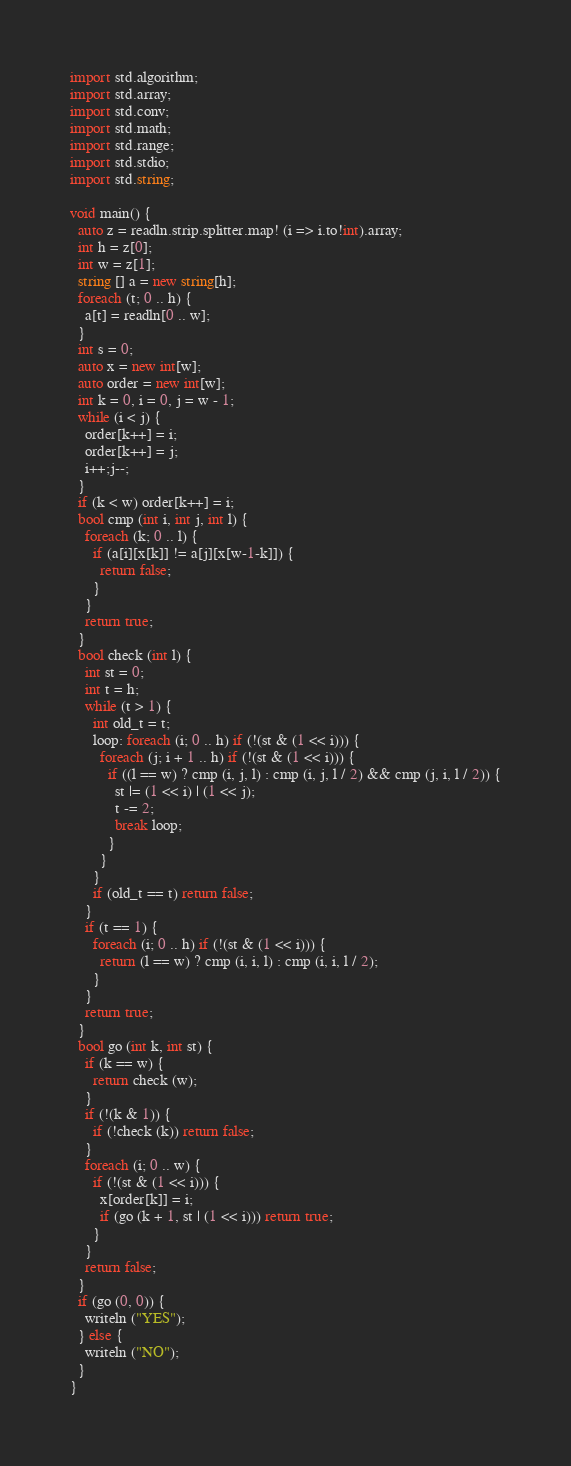Convert code to text. <code><loc_0><loc_0><loc_500><loc_500><_D_>import std.algorithm;
import std.array;
import std.conv;
import std.math;
import std.range;
import std.stdio;
import std.string;

void main() {
  auto z = readln.strip.splitter.map! (i => i.to!int).array;
  int h = z[0];
  int w = z[1];
  string [] a = new string[h];
  foreach (t; 0 .. h) {
    a[t] = readln[0 .. w];
  }
  int s = 0;
  auto x = new int[w];
  auto order = new int[w];
  int k = 0, i = 0, j = w - 1;
  while (i < j) {
    order[k++] = i;
    order[k++] = j;
    i++;j--;
  }
  if (k < w) order[k++] = i;
  bool cmp (int i, int j, int l) {
    foreach (k; 0 .. l) {
      if (a[i][x[k]] != a[j][x[w-1-k]]) {
        return false;
      }
    }
    return true;
  }
  bool check (int l) {
    int st = 0;
    int t = h;
    while (t > 1) {
      int old_t = t;
      loop: foreach (i; 0 .. h) if (!(st & (1 << i))) {
        foreach (j; i + 1 .. h) if (!(st & (1 << i))) {
          if ((l == w) ? cmp (i, j, l) : cmp (i, j, l / 2) && cmp (j, i, l / 2)) {
            st |= (1 << i) | (1 << j);
            t -= 2;
            break loop;
          }
        }
      }
      if (old_t == t) return false;
    }
    if (t == 1) {
      foreach (i; 0 .. h) if (!(st & (1 << i))) {
        return (l == w) ? cmp (i, i, l) : cmp (i, i, l / 2);
      }
    }
    return true;
  }
  bool go (int k, int st) {
    if (k == w) {
      return check (w); 
    }
    if (!(k & 1)) {
      if (!check (k)) return false;
    }
    foreach (i; 0 .. w) {
      if (!(st & (1 << i))) {
        x[order[k]] = i;
        if (go (k + 1, st | (1 << i))) return true;
      }
    }
    return false;
  }
  if (go (0, 0)) {
    writeln ("YES");
  } else {
    writeln ("NO");
  }
}

</code> 